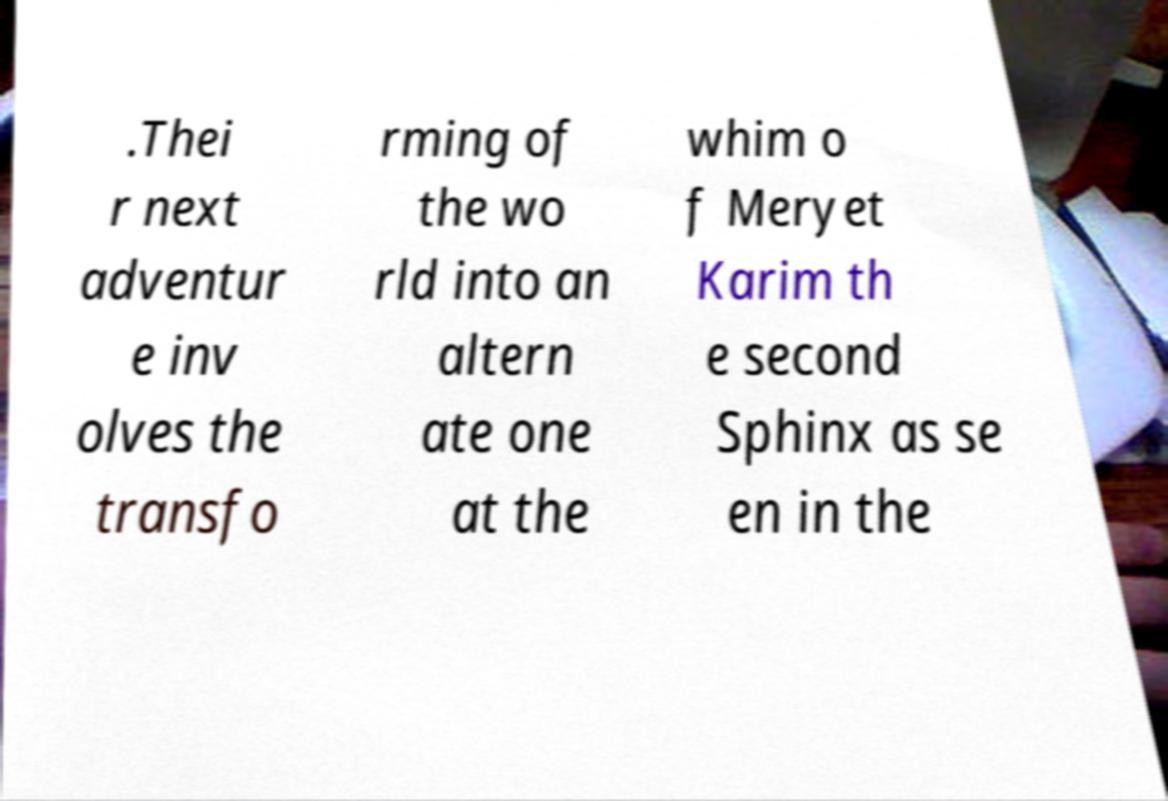Can you read and provide the text displayed in the image?This photo seems to have some interesting text. Can you extract and type it out for me? .Thei r next adventur e inv olves the transfo rming of the wo rld into an altern ate one at the whim o f Meryet Karim th e second Sphinx as se en in the 